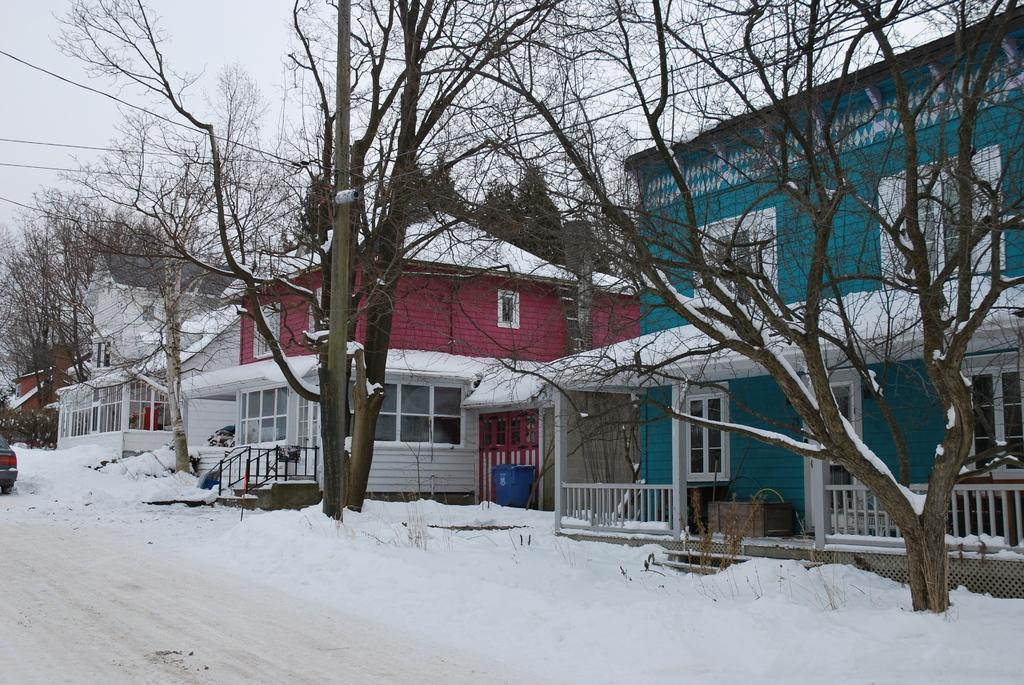What is located in the center of the image? There are trees in the center of the image. What object can be seen in the image besides the trees? There is a pole in the image. What type of structures are visible in the background of the image? There are houses in the background of the image. What type of weather condition is depicted in the image? There is snow at the bottom of the image, indicating a snowy condition. What type of news can be heard coming from the houses in the image? There is no indication in the image that news is being broadcast or heard from the houses. 